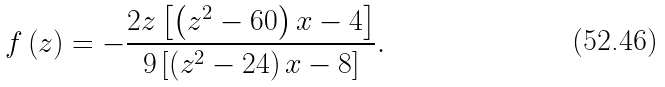<formula> <loc_0><loc_0><loc_500><loc_500>f \left ( z \right ) = - \frac { 2 z \left [ \left ( z ^ { 2 } - 6 0 \right ) x - 4 \right ] } { 9 \left [ \left ( z ^ { 2 } - 2 4 \right ) x - 8 \right ] } .</formula> 